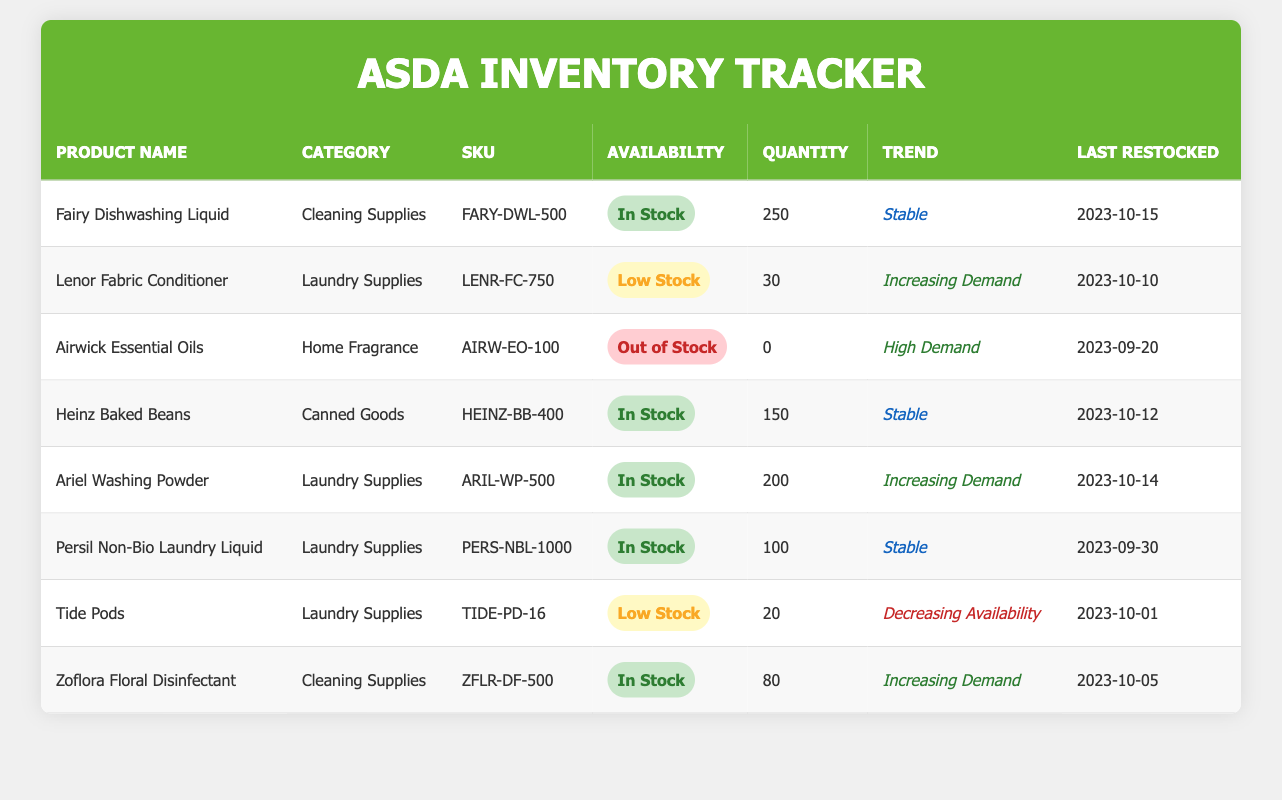What is the availability status of Ariel Washing Powder? According to the table, Ariel Washing Powder has an availability status listed as "In Stock."
Answer: In Stock How many units of Lenor Fabric Conditioner are currently available? The table indicates that there are 30 units of Lenor Fabric Conditioner available.
Answer: 30 Is Airwick Essential Oils currently available? The table states that Airwick Essential Oils is "Out of Stock," indicating that it is not available.
Answer: No What is the most recently restocked item from the Cleaning Supplies category? Reviewing the Cleaning Supplies section, Fairy Dishwashing Liquid was restocked on 2023-10-15, which is the most recent date for that category.
Answer: Fairy Dishwashing Liquid What is the total quantity available for all Laundry Supplies products? To find the total, add the quantities of the Laundry Supplies: Lenor (30) + Ariel (200) + Persil (100) + Tide Pods (20) = 350. Thus, the total quantity is 350.
Answer: 350 Is the demand for Zoflora Floral Disinfectant increasing? The table indicates that Zoflora Floral Disinfectant has a recent trend labeled as "Increasing Demand," confirming that demand is indeed rising.
Answer: Yes Which product has the highest quantity available in stock? Upon examining the quantities, Fairy Dishwashing Liquid has the highest availability at 250 units, compared to other products listed.
Answer: Fairy Dishwashing Liquid How many items are currently marked as Low Stock in the inventory? There are two items marked as Low Stock: Lenor Fabric Conditioner (30 units) and Tide Pods (20 units). Therefore, the total is 2 items.
Answer: 2 Which product has the most recent restock date? After checking the restock dates for all items, Fairy Dishwashing Liquid has the latest restock date of 2023-10-15, making it the most recent.
Answer: Fairy Dishwashing Liquid What is the trend for the availability of Tide Pods? The table shows that Tide Pods are in a "Decreasing Availability" trend, indicating that the stock is getting lower.
Answer: Decreasing Availability 